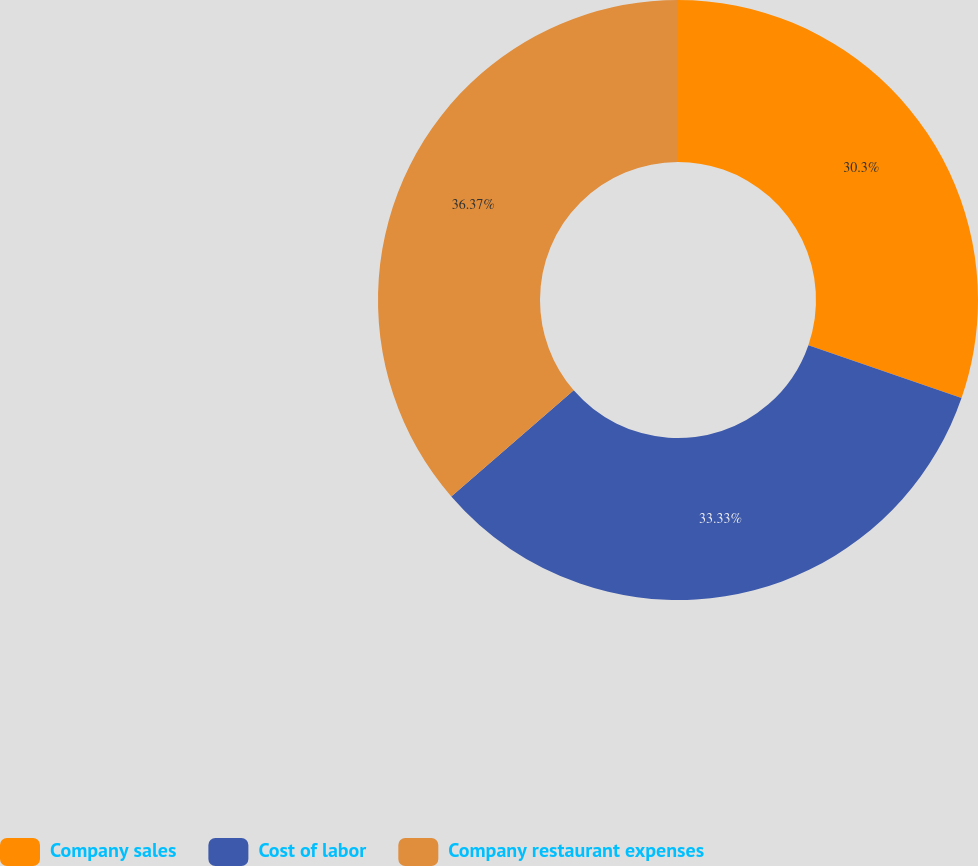<chart> <loc_0><loc_0><loc_500><loc_500><pie_chart><fcel>Company sales<fcel>Cost of labor<fcel>Company restaurant expenses<nl><fcel>30.3%<fcel>33.33%<fcel>36.36%<nl></chart> 